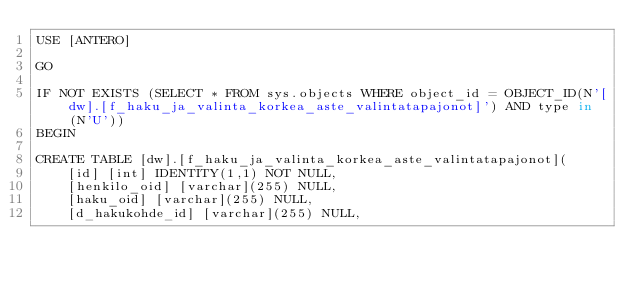Convert code to text. <code><loc_0><loc_0><loc_500><loc_500><_SQL_>USE [ANTERO]

GO

IF NOT EXISTS (SELECT * FROM sys.objects WHERE object_id = OBJECT_ID(N'[dw].[f_haku_ja_valinta_korkea_aste_valintatapajonot]') AND type in (N'U'))
BEGIN

CREATE TABLE [dw].[f_haku_ja_valinta_korkea_aste_valintatapajonot](
	[id] [int] IDENTITY(1,1) NOT NULL,
	[henkilo_oid] [varchar](255) NULL,
	[haku_oid] [varchar](255) NULL,
	[d_hakukohde_id] [varchar](255) NULL,</code> 